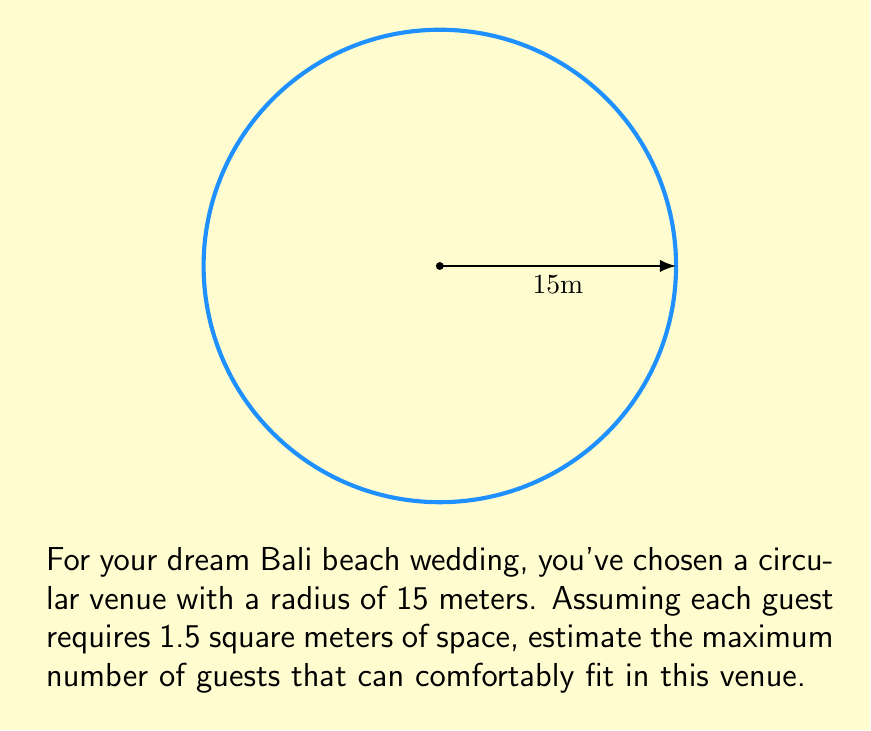Show me your answer to this math problem. Let's approach this step-by-step:

1) First, we need to calculate the area of the circular venue:
   Area of a circle = $\pi r^2$
   where $r$ is the radius

   Area = $\pi * 15^2 = 225\pi$ square meters

2) Now, we know each guest requires 1.5 square meters of space.
   To find the number of guests, we divide the total area by the space per guest:

   Number of guests = $\frac{\text{Total Area}}{\text{Space per guest}}$

3) Substituting our values:
   Number of guests = $\frac{225\pi}{1.5}$

4) Simplifying:
   Number of guests = $150\pi \approx 471.24$

5) Since we can't have a fractional guest, we round down to the nearest whole number.

Therefore, the maximum number of guests that can comfortably fit is 471.
Answer: 471 guests 